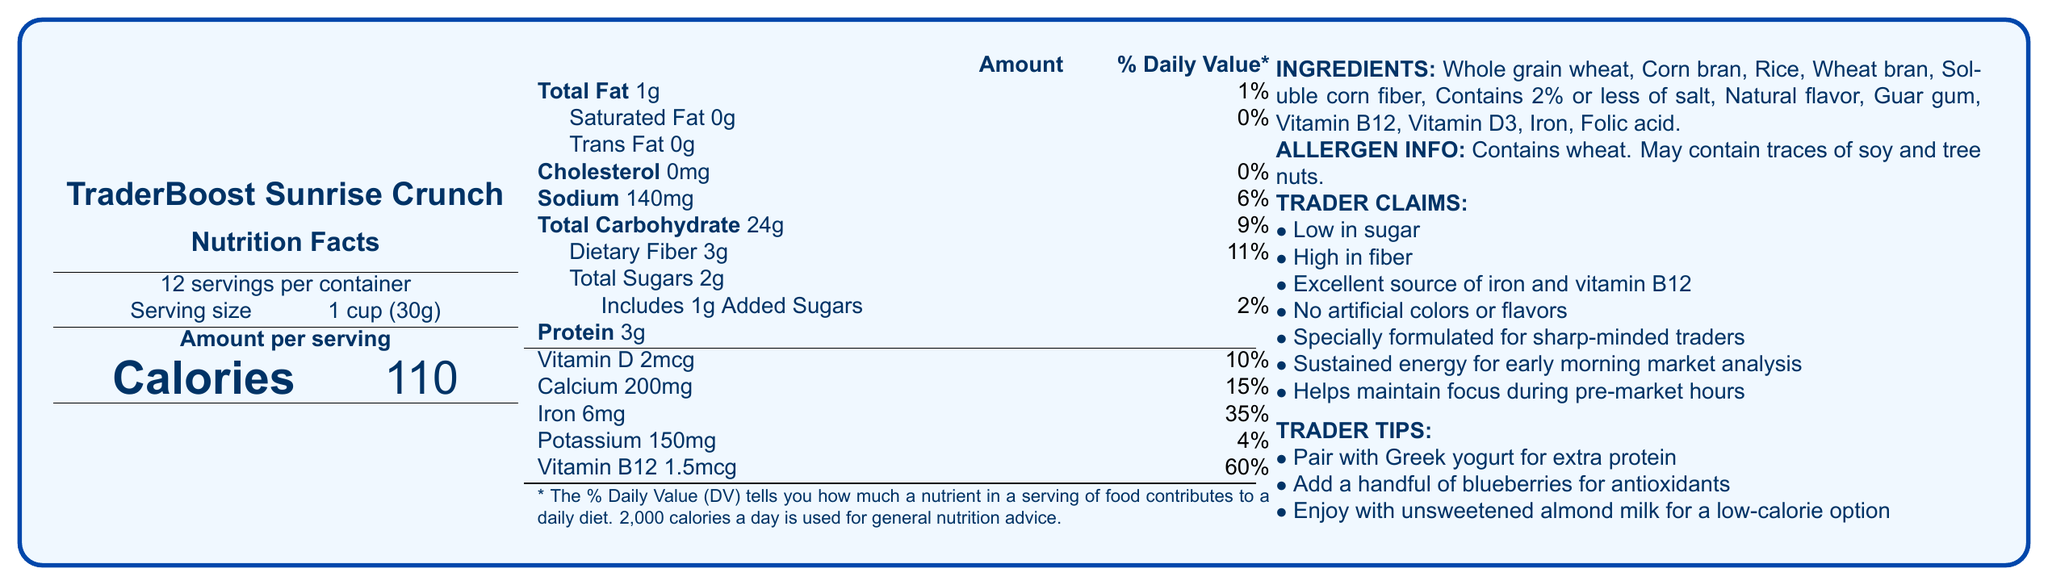What is the serving size of TraderBoost Sunrise Crunch? The document states that the serving size is 1 cup (30g).
Answer: 1 cup (30g) How many servings are there per container? According to the document, there are 12 servings per container.
Answer: 12 servings What is the total amount of protein in one serving? The Nutrition Facts section lists the protein content as 3g per serving.
Answer: 3g How much iron is provided per serving as a percentage of the daily value? The document states that each serving provides 35% of the daily value for iron.
Answer: 35% What allergen information is listed for TraderBoost Sunrise Crunch? The allergen information section of the document mentions that the product contains wheat and may contain traces of soy and tree nuts.
Answer: Contains wheat. May contain traces of soy and tree nuts. What is the main marketing claim for TraderBoost Sunrise Crunch? A. Low in calories B. Specially formulated for sharp-minded traders C. Contains artificial colors D. High in sugar The marketing claim section mentions that the product is "specially formulated for sharp-minded traders."
Answer: B Which of the following is not an ingredient in TraderBoost Sunrise Crunch? 1. Whole grain wheat 2. Honey 3. Corn bran 4. Vitamin D3 The listed ingredients include whole grain wheat, corn bran, and vitamin D3, but honey is not included.
Answer: 2 Is TraderBoost Sunrise Crunch high in fiber? The claims state that the product is high in fiber. Additionally, the Nutrition Facts show 3g of dietary fiber per serving, which is 11% of the daily value.
Answer: Yes Does the product contain any added sugars? The document indicates that the product includes 1g of added sugars per serving.
Answer: Yes Summarize the main features and claims of TraderBoost Sunrise Crunch. The document describes TraderBoost Sunrise Crunch, highlighting its nutritional benefits, ingredients, allergen information, and specific marketing claims targeted at traders.
Answer: TraderBoost Sunrise Crunch is a low-sugar breakfast cereal designed for early morning market analysis. It has a serving size of 1 cup (30g) and provides 110 calories per serving. The cereal is high in fiber, rich in iron and vitamin B12, and free of artificial colors and flavors. It is marketed as specially formulated for traders to maintain focus during pre-market hours. Ingredients include whole grain wheat, corn bran, and various vitamins and minerals. Allergen information notes the presence of wheat and possible traces of soy and tree nuts. What is the production process for TraderBoost Sunrise Crunch? The document does not provide any information on the production process of the cereal.
Answer: Cannot be determined 